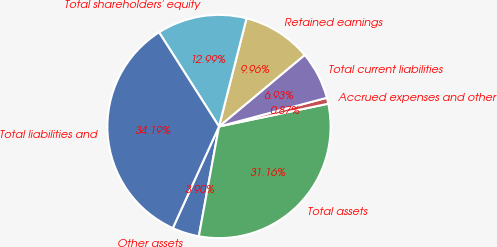Convert chart. <chart><loc_0><loc_0><loc_500><loc_500><pie_chart><fcel>Other assets<fcel>Total assets<fcel>Accrued expenses and other<fcel>Total current liabilities<fcel>Retained earnings<fcel>Total shareholders' equity<fcel>Total liabilities and<nl><fcel>3.9%<fcel>31.16%<fcel>0.87%<fcel>6.93%<fcel>9.96%<fcel>12.99%<fcel>34.19%<nl></chart> 